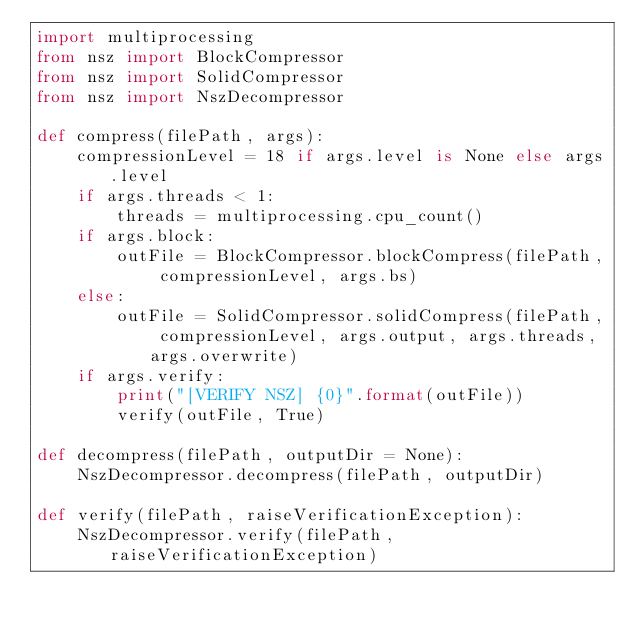Convert code to text. <code><loc_0><loc_0><loc_500><loc_500><_Python_>import multiprocessing
from nsz import BlockCompressor
from nsz import SolidCompressor
from nsz import NszDecompressor

def compress(filePath, args):
	compressionLevel = 18 if args.level is None else args.level
	if args.threads < 1:
		threads = multiprocessing.cpu_count()
	if args.block:
		outFile = BlockCompressor.blockCompress(filePath, compressionLevel, args.bs)
	else:
		outFile = SolidCompressor.solidCompress(filePath, compressionLevel, args.output, args.threads, args.overwrite)
	if args.verify:
		print("[VERIFY NSZ] {0}".format(outFile))
		verify(outFile, True)

def decompress(filePath, outputDir = None):
	NszDecompressor.decompress(filePath, outputDir)

def verify(filePath, raiseVerificationException):
	NszDecompressor.verify(filePath, raiseVerificationException)
</code> 